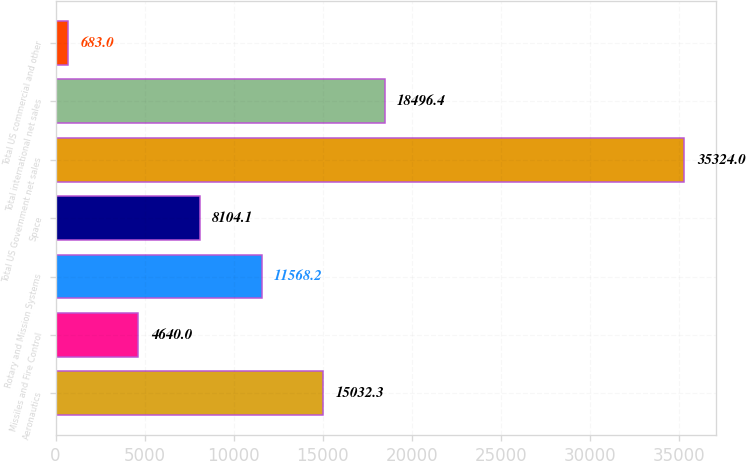Convert chart. <chart><loc_0><loc_0><loc_500><loc_500><bar_chart><fcel>Aeronautics<fcel>Missiles and Fire Control<fcel>Rotary and Mission Systems<fcel>Space<fcel>Total US Government net sales<fcel>Total international net sales<fcel>Total US commercial and other<nl><fcel>15032.3<fcel>4640<fcel>11568.2<fcel>8104.1<fcel>35324<fcel>18496.4<fcel>683<nl></chart> 